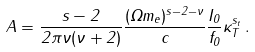<formula> <loc_0><loc_0><loc_500><loc_500>A = \frac { s - 2 } { 2 \pi \nu ( \nu + 2 ) } \frac { ( \Omega m _ { e } ) ^ { s - 2 - \nu } } { c } \frac { I _ { 0 } } { f _ { 0 } } \kappa _ { T } ^ { s _ { t } } \, .</formula> 